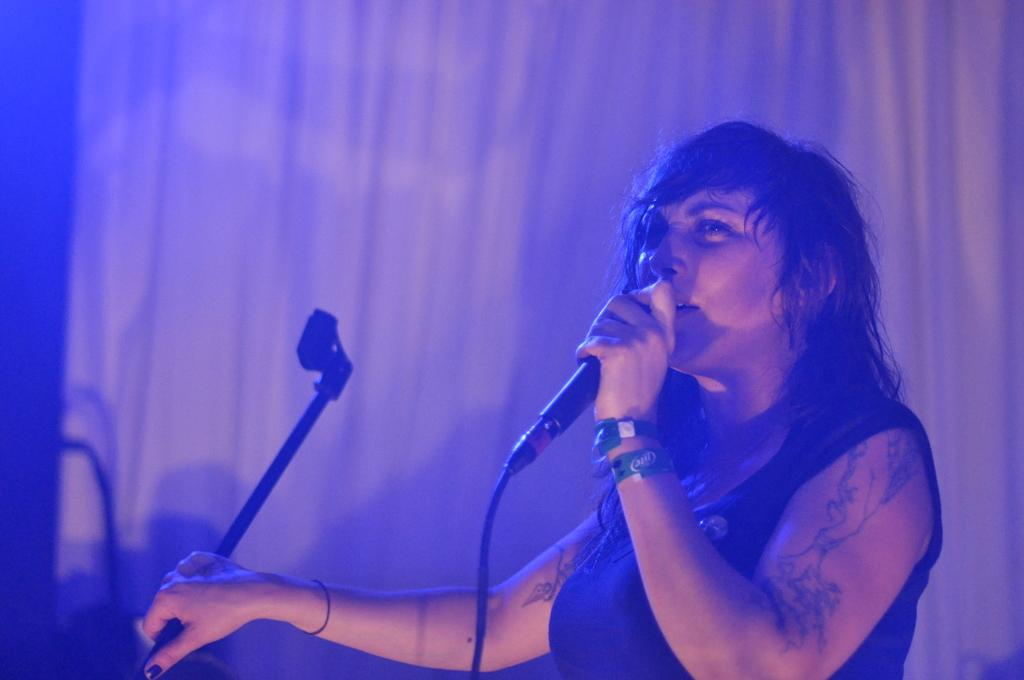Who is the main subject in the image? There is a lady in the image. What is the lady doing in the image? The lady is singing on a mic. Can you describe any unique features of the lady? The lady has a tattoo on her hands. What type of arch can be seen in the background of the image? There is no arch present in the image. How many pears are visible on the table in the image? There are no pears visible in the image. 